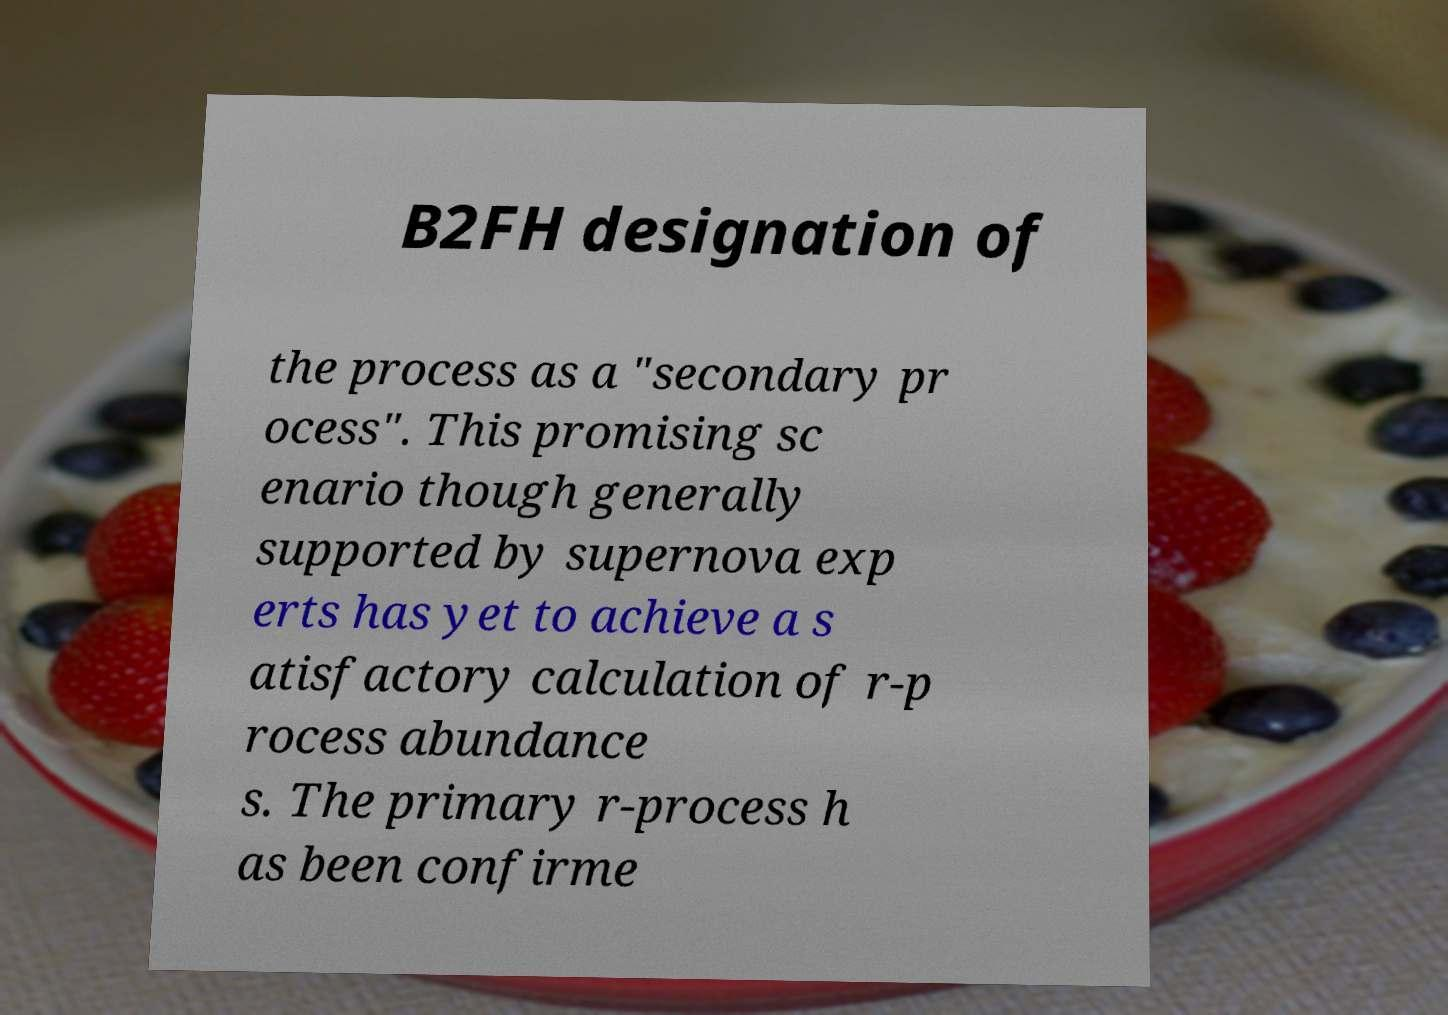Please identify and transcribe the text found in this image. B2FH designation of the process as a "secondary pr ocess". This promising sc enario though generally supported by supernova exp erts has yet to achieve a s atisfactory calculation of r-p rocess abundance s. The primary r-process h as been confirme 